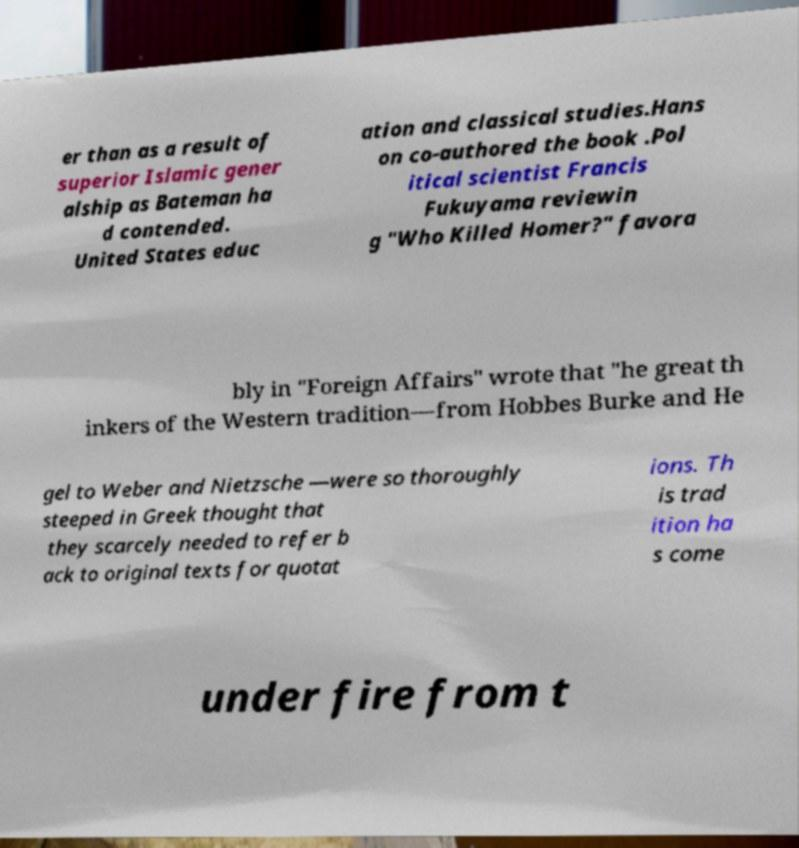What messages or text are displayed in this image? I need them in a readable, typed format. er than as a result of superior Islamic gener alship as Bateman ha d contended. United States educ ation and classical studies.Hans on co-authored the book .Pol itical scientist Francis Fukuyama reviewin g "Who Killed Homer?" favora bly in "Foreign Affairs" wrote that "he great th inkers of the Western tradition—from Hobbes Burke and He gel to Weber and Nietzsche —were so thoroughly steeped in Greek thought that they scarcely needed to refer b ack to original texts for quotat ions. Th is trad ition ha s come under fire from t 